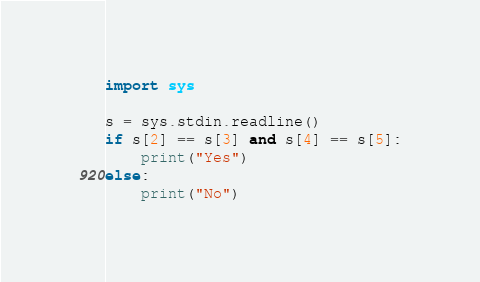<code> <loc_0><loc_0><loc_500><loc_500><_Python_>import sys

s = sys.stdin.readline()
if s[2] == s[3] and s[4] == s[5]:
    print("Yes")
else:
    print("No")
</code> 